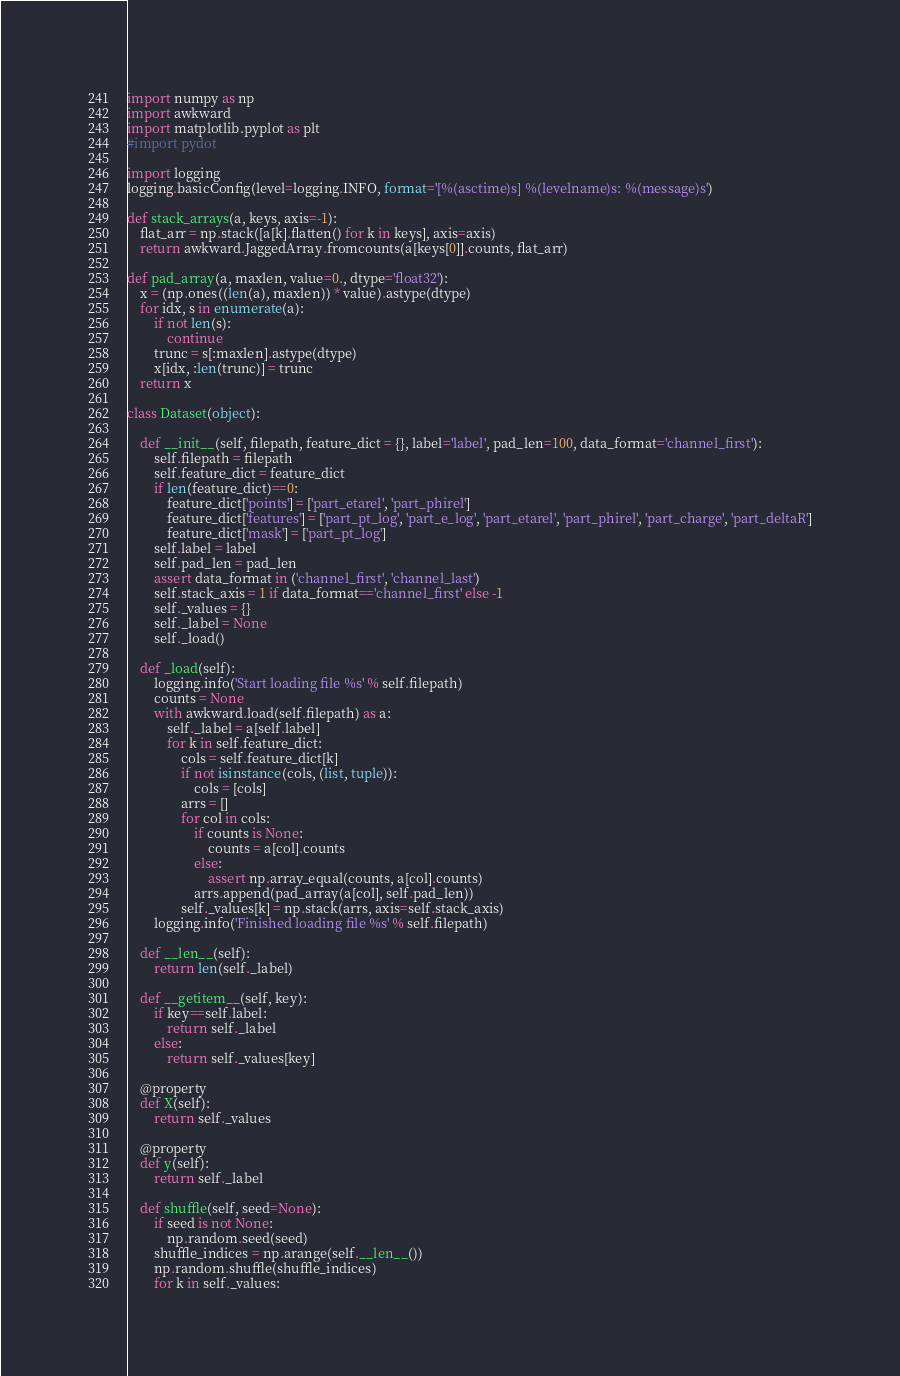Convert code to text. <code><loc_0><loc_0><loc_500><loc_500><_Python_>import numpy as np
import awkward
import matplotlib.pyplot as plt
#import pydot

import logging
logging.basicConfig(level=logging.INFO, format='[%(asctime)s] %(levelname)s: %(message)s')

def stack_arrays(a, keys, axis=-1):
    flat_arr = np.stack([a[k].flatten() for k in keys], axis=axis)
    return awkward.JaggedArray.fromcounts(a[keys[0]].counts, flat_arr)

def pad_array(a, maxlen, value=0., dtype='float32'):
    x = (np.ones((len(a), maxlen)) * value).astype(dtype)
    for idx, s in enumerate(a):
        if not len(s):
            continue
        trunc = s[:maxlen].astype(dtype)
        x[idx, :len(trunc)] = trunc
    return x

class Dataset(object):

    def __init__(self, filepath, feature_dict = {}, label='label', pad_len=100, data_format='channel_first'):
        self.filepath = filepath
        self.feature_dict = feature_dict
        if len(feature_dict)==0:
            feature_dict['points'] = ['part_etarel', 'part_phirel']
            feature_dict['features'] = ['part_pt_log', 'part_e_log', 'part_etarel', 'part_phirel', 'part_charge', 'part_deltaR']
            feature_dict['mask'] = ['part_pt_log']
        self.label = label
        self.pad_len = pad_len
        assert data_format in ('channel_first', 'channel_last')
        self.stack_axis = 1 if data_format=='channel_first' else -1
        self._values = {}
        self._label = None
        self._load()

    def _load(self):
        logging.info('Start loading file %s' % self.filepath)
        counts = None
        with awkward.load(self.filepath) as a:
            self._label = a[self.label]
            for k in self.feature_dict:
                cols = self.feature_dict[k]
                if not isinstance(cols, (list, tuple)):
                    cols = [cols]
                arrs = []
                for col in cols:
                    if counts is None:
                        counts = a[col].counts
                    else:
                        assert np.array_equal(counts, a[col].counts)
                    arrs.append(pad_array(a[col], self.pad_len))
                self._values[k] = np.stack(arrs, axis=self.stack_axis)
        logging.info('Finished loading file %s' % self.filepath)

    def __len__(self):
        return len(self._label)

    def __getitem__(self, key):
        if key==self.label:
            return self._label
        else:
            return self._values[key]
    
    @property
    def X(self):
        return self._values
    
    @property
    def y(self):
        return self._label

    def shuffle(self, seed=None):
        if seed is not None:
            np.random.seed(seed)
        shuffle_indices = np.arange(self.__len__())
        np.random.shuffle(shuffle_indices)
        for k in self._values:</code> 